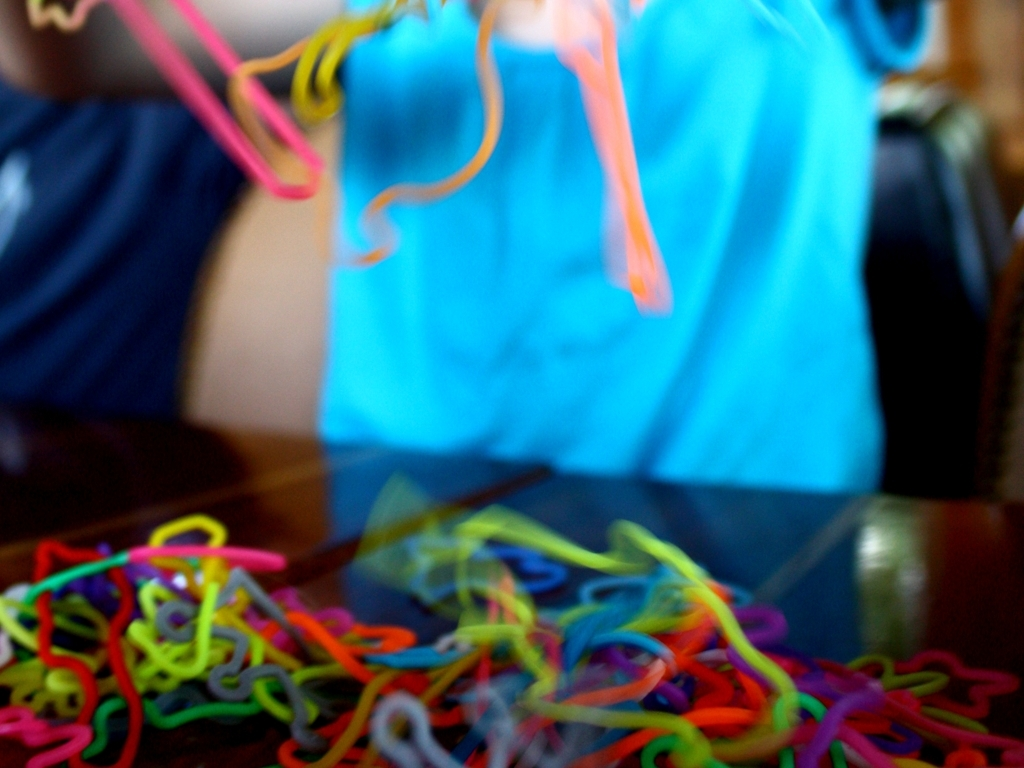Could you tell me more about the setting of this image? The picture is taken indoors, on a wooden surface that appears to be a table or a floor. The out-of-focus area suggests a domestic or classroom setting where such playful and educational activities might take place. 